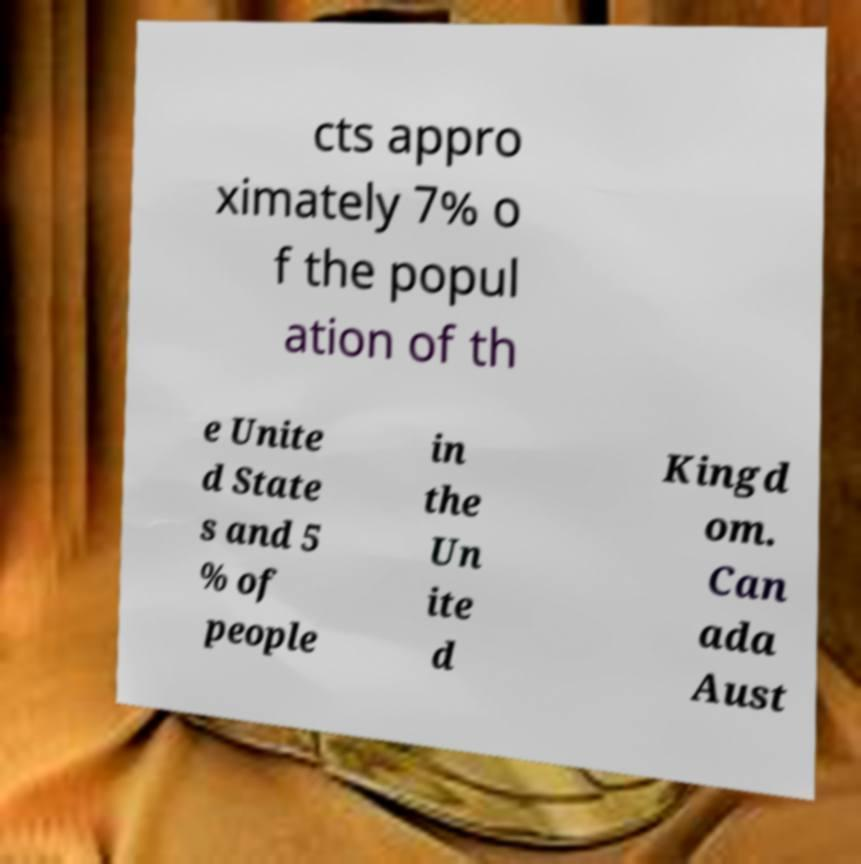Could you assist in decoding the text presented in this image and type it out clearly? cts appro ximately 7% o f the popul ation of th e Unite d State s and 5 % of people in the Un ite d Kingd om. Can ada Aust 